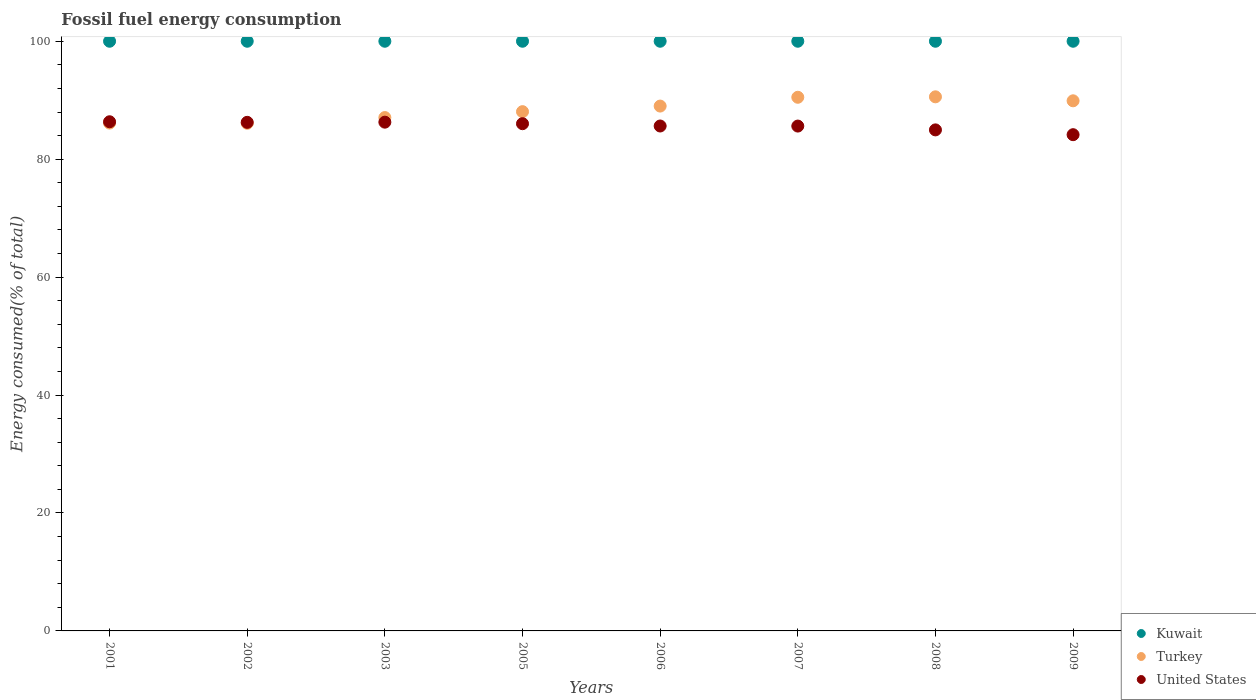How many different coloured dotlines are there?
Your answer should be very brief. 3. What is the percentage of energy consumed in United States in 2009?
Provide a succinct answer. 84.15. Across all years, what is the maximum percentage of energy consumed in Turkey?
Provide a short and direct response. 90.57. Across all years, what is the minimum percentage of energy consumed in Kuwait?
Give a very brief answer. 100. What is the total percentage of energy consumed in Turkey in the graph?
Offer a very short reply. 707.31. What is the difference between the percentage of energy consumed in Kuwait in 2005 and that in 2008?
Offer a terse response. 3.467057993589151e-6. What is the difference between the percentage of energy consumed in Kuwait in 2003 and the percentage of energy consumed in Turkey in 2008?
Your response must be concise. 9.43. What is the average percentage of energy consumed in Kuwait per year?
Ensure brevity in your answer.  100. In the year 2005, what is the difference between the percentage of energy consumed in United States and percentage of energy consumed in Kuwait?
Provide a succinct answer. -13.98. In how many years, is the percentage of energy consumed in United States greater than 60 %?
Give a very brief answer. 8. What is the ratio of the percentage of energy consumed in Turkey in 2007 to that in 2009?
Offer a terse response. 1.01. Is the percentage of energy consumed in United States in 2005 less than that in 2009?
Make the answer very short. No. What is the difference between the highest and the second highest percentage of energy consumed in United States?
Keep it short and to the point. 0.07. What is the difference between the highest and the lowest percentage of energy consumed in Turkey?
Make the answer very short. 4.49. In how many years, is the percentage of energy consumed in United States greater than the average percentage of energy consumed in United States taken over all years?
Your answer should be compact. 4. Is it the case that in every year, the sum of the percentage of energy consumed in Kuwait and percentage of energy consumed in Turkey  is greater than the percentage of energy consumed in United States?
Offer a terse response. Yes. Does the percentage of energy consumed in United States monotonically increase over the years?
Provide a short and direct response. No. Is the percentage of energy consumed in United States strictly less than the percentage of energy consumed in Kuwait over the years?
Ensure brevity in your answer.  Yes. How many dotlines are there?
Ensure brevity in your answer.  3. How many years are there in the graph?
Give a very brief answer. 8. Are the values on the major ticks of Y-axis written in scientific E-notation?
Your response must be concise. No. How many legend labels are there?
Your answer should be very brief. 3. How are the legend labels stacked?
Give a very brief answer. Vertical. What is the title of the graph?
Your response must be concise. Fossil fuel energy consumption. Does "New Caledonia" appear as one of the legend labels in the graph?
Give a very brief answer. No. What is the label or title of the Y-axis?
Your answer should be very brief. Energy consumed(% of total). What is the Energy consumed(% of total) of Turkey in 2001?
Provide a succinct answer. 86.12. What is the Energy consumed(% of total) in United States in 2001?
Keep it short and to the point. 86.35. What is the Energy consumed(% of total) of Kuwait in 2002?
Your answer should be very brief. 100. What is the Energy consumed(% of total) of Turkey in 2002?
Make the answer very short. 86.09. What is the Energy consumed(% of total) in United States in 2002?
Offer a very short reply. 86.25. What is the Energy consumed(% of total) in Kuwait in 2003?
Your response must be concise. 100. What is the Energy consumed(% of total) in Turkey in 2003?
Your response must be concise. 87.06. What is the Energy consumed(% of total) in United States in 2003?
Keep it short and to the point. 86.28. What is the Energy consumed(% of total) in Turkey in 2005?
Your answer should be compact. 88.06. What is the Energy consumed(% of total) of United States in 2005?
Provide a succinct answer. 86.02. What is the Energy consumed(% of total) of Kuwait in 2006?
Give a very brief answer. 100. What is the Energy consumed(% of total) of Turkey in 2006?
Ensure brevity in your answer.  89.01. What is the Energy consumed(% of total) of United States in 2006?
Give a very brief answer. 85.63. What is the Energy consumed(% of total) in Turkey in 2007?
Ensure brevity in your answer.  90.5. What is the Energy consumed(% of total) in United States in 2007?
Your response must be concise. 85.61. What is the Energy consumed(% of total) of Kuwait in 2008?
Ensure brevity in your answer.  100. What is the Energy consumed(% of total) of Turkey in 2008?
Your response must be concise. 90.57. What is the Energy consumed(% of total) in United States in 2008?
Provide a succinct answer. 84.97. What is the Energy consumed(% of total) of Turkey in 2009?
Give a very brief answer. 89.9. What is the Energy consumed(% of total) of United States in 2009?
Your answer should be compact. 84.15. Across all years, what is the maximum Energy consumed(% of total) in Turkey?
Offer a terse response. 90.57. Across all years, what is the maximum Energy consumed(% of total) in United States?
Your answer should be compact. 86.35. Across all years, what is the minimum Energy consumed(% of total) in Kuwait?
Make the answer very short. 100. Across all years, what is the minimum Energy consumed(% of total) of Turkey?
Offer a terse response. 86.09. Across all years, what is the minimum Energy consumed(% of total) in United States?
Offer a very short reply. 84.15. What is the total Energy consumed(% of total) in Kuwait in the graph?
Your response must be concise. 800. What is the total Energy consumed(% of total) of Turkey in the graph?
Offer a very short reply. 707.31. What is the total Energy consumed(% of total) in United States in the graph?
Give a very brief answer. 685.26. What is the difference between the Energy consumed(% of total) in Turkey in 2001 and that in 2002?
Offer a very short reply. 0.04. What is the difference between the Energy consumed(% of total) of United States in 2001 and that in 2002?
Offer a terse response. 0.1. What is the difference between the Energy consumed(% of total) in Kuwait in 2001 and that in 2003?
Ensure brevity in your answer.  0. What is the difference between the Energy consumed(% of total) of Turkey in 2001 and that in 2003?
Give a very brief answer. -0.93. What is the difference between the Energy consumed(% of total) in United States in 2001 and that in 2003?
Ensure brevity in your answer.  0.07. What is the difference between the Energy consumed(% of total) in Kuwait in 2001 and that in 2005?
Provide a short and direct response. 0. What is the difference between the Energy consumed(% of total) in Turkey in 2001 and that in 2005?
Give a very brief answer. -1.94. What is the difference between the Energy consumed(% of total) in United States in 2001 and that in 2005?
Ensure brevity in your answer.  0.33. What is the difference between the Energy consumed(% of total) of Turkey in 2001 and that in 2006?
Your answer should be very brief. -2.88. What is the difference between the Energy consumed(% of total) of United States in 2001 and that in 2006?
Make the answer very short. 0.72. What is the difference between the Energy consumed(% of total) of Turkey in 2001 and that in 2007?
Make the answer very short. -4.37. What is the difference between the Energy consumed(% of total) of United States in 2001 and that in 2007?
Make the answer very short. 0.73. What is the difference between the Energy consumed(% of total) in Turkey in 2001 and that in 2008?
Your answer should be compact. -4.45. What is the difference between the Energy consumed(% of total) of United States in 2001 and that in 2008?
Offer a terse response. 1.38. What is the difference between the Energy consumed(% of total) in Kuwait in 2001 and that in 2009?
Provide a short and direct response. 0. What is the difference between the Energy consumed(% of total) in Turkey in 2001 and that in 2009?
Provide a succinct answer. -3.78. What is the difference between the Energy consumed(% of total) of United States in 2001 and that in 2009?
Offer a very short reply. 2.19. What is the difference between the Energy consumed(% of total) in Turkey in 2002 and that in 2003?
Your answer should be compact. -0.97. What is the difference between the Energy consumed(% of total) in United States in 2002 and that in 2003?
Your answer should be compact. -0.03. What is the difference between the Energy consumed(% of total) in Turkey in 2002 and that in 2005?
Provide a short and direct response. -1.97. What is the difference between the Energy consumed(% of total) in United States in 2002 and that in 2005?
Ensure brevity in your answer.  0.23. What is the difference between the Energy consumed(% of total) in Kuwait in 2002 and that in 2006?
Give a very brief answer. 0. What is the difference between the Energy consumed(% of total) of Turkey in 2002 and that in 2006?
Provide a succinct answer. -2.92. What is the difference between the Energy consumed(% of total) in United States in 2002 and that in 2006?
Keep it short and to the point. 0.62. What is the difference between the Energy consumed(% of total) in Kuwait in 2002 and that in 2007?
Offer a very short reply. 0. What is the difference between the Energy consumed(% of total) of Turkey in 2002 and that in 2007?
Make the answer very short. -4.41. What is the difference between the Energy consumed(% of total) in United States in 2002 and that in 2007?
Offer a terse response. 0.63. What is the difference between the Energy consumed(% of total) of Turkey in 2002 and that in 2008?
Your answer should be very brief. -4.49. What is the difference between the Energy consumed(% of total) in United States in 2002 and that in 2008?
Make the answer very short. 1.28. What is the difference between the Energy consumed(% of total) in Turkey in 2002 and that in 2009?
Provide a succinct answer. -3.81. What is the difference between the Energy consumed(% of total) of United States in 2002 and that in 2009?
Your answer should be compact. 2.09. What is the difference between the Energy consumed(% of total) in Kuwait in 2003 and that in 2005?
Provide a succinct answer. -0. What is the difference between the Energy consumed(% of total) in Turkey in 2003 and that in 2005?
Offer a very short reply. -1. What is the difference between the Energy consumed(% of total) in United States in 2003 and that in 2005?
Keep it short and to the point. 0.26. What is the difference between the Energy consumed(% of total) of Turkey in 2003 and that in 2006?
Your answer should be compact. -1.95. What is the difference between the Energy consumed(% of total) in United States in 2003 and that in 2006?
Provide a succinct answer. 0.65. What is the difference between the Energy consumed(% of total) in Kuwait in 2003 and that in 2007?
Provide a succinct answer. -0. What is the difference between the Energy consumed(% of total) in Turkey in 2003 and that in 2007?
Keep it short and to the point. -3.44. What is the difference between the Energy consumed(% of total) in United States in 2003 and that in 2007?
Offer a terse response. 0.66. What is the difference between the Energy consumed(% of total) in Kuwait in 2003 and that in 2008?
Give a very brief answer. -0. What is the difference between the Energy consumed(% of total) of Turkey in 2003 and that in 2008?
Offer a terse response. -3.52. What is the difference between the Energy consumed(% of total) in United States in 2003 and that in 2008?
Offer a terse response. 1.31. What is the difference between the Energy consumed(% of total) of Kuwait in 2003 and that in 2009?
Offer a very short reply. -0. What is the difference between the Energy consumed(% of total) of Turkey in 2003 and that in 2009?
Ensure brevity in your answer.  -2.84. What is the difference between the Energy consumed(% of total) in United States in 2003 and that in 2009?
Offer a terse response. 2.12. What is the difference between the Energy consumed(% of total) in Kuwait in 2005 and that in 2006?
Make the answer very short. 0. What is the difference between the Energy consumed(% of total) of Turkey in 2005 and that in 2006?
Provide a succinct answer. -0.95. What is the difference between the Energy consumed(% of total) of United States in 2005 and that in 2006?
Your response must be concise. 0.39. What is the difference between the Energy consumed(% of total) of Turkey in 2005 and that in 2007?
Your answer should be very brief. -2.44. What is the difference between the Energy consumed(% of total) in United States in 2005 and that in 2007?
Keep it short and to the point. 0.4. What is the difference between the Energy consumed(% of total) of Kuwait in 2005 and that in 2008?
Offer a terse response. 0. What is the difference between the Energy consumed(% of total) in Turkey in 2005 and that in 2008?
Offer a very short reply. -2.52. What is the difference between the Energy consumed(% of total) of United States in 2005 and that in 2008?
Provide a succinct answer. 1.05. What is the difference between the Energy consumed(% of total) of Kuwait in 2005 and that in 2009?
Keep it short and to the point. 0. What is the difference between the Energy consumed(% of total) of Turkey in 2005 and that in 2009?
Keep it short and to the point. -1.84. What is the difference between the Energy consumed(% of total) in United States in 2005 and that in 2009?
Your response must be concise. 1.86. What is the difference between the Energy consumed(% of total) in Kuwait in 2006 and that in 2007?
Offer a very short reply. 0. What is the difference between the Energy consumed(% of total) of Turkey in 2006 and that in 2007?
Give a very brief answer. -1.49. What is the difference between the Energy consumed(% of total) of United States in 2006 and that in 2007?
Your answer should be compact. 0.01. What is the difference between the Energy consumed(% of total) in Kuwait in 2006 and that in 2008?
Keep it short and to the point. 0. What is the difference between the Energy consumed(% of total) in Turkey in 2006 and that in 2008?
Keep it short and to the point. -1.57. What is the difference between the Energy consumed(% of total) of United States in 2006 and that in 2008?
Your answer should be compact. 0.66. What is the difference between the Energy consumed(% of total) of Turkey in 2006 and that in 2009?
Your answer should be very brief. -0.89. What is the difference between the Energy consumed(% of total) in United States in 2006 and that in 2009?
Provide a short and direct response. 1.47. What is the difference between the Energy consumed(% of total) of Turkey in 2007 and that in 2008?
Offer a very short reply. -0.08. What is the difference between the Energy consumed(% of total) in United States in 2007 and that in 2008?
Keep it short and to the point. 0.65. What is the difference between the Energy consumed(% of total) in Turkey in 2007 and that in 2009?
Offer a terse response. 0.6. What is the difference between the Energy consumed(% of total) in United States in 2007 and that in 2009?
Give a very brief answer. 1.46. What is the difference between the Energy consumed(% of total) of Kuwait in 2008 and that in 2009?
Provide a short and direct response. -0. What is the difference between the Energy consumed(% of total) of Turkey in 2008 and that in 2009?
Ensure brevity in your answer.  0.68. What is the difference between the Energy consumed(% of total) of United States in 2008 and that in 2009?
Keep it short and to the point. 0.81. What is the difference between the Energy consumed(% of total) of Kuwait in 2001 and the Energy consumed(% of total) of Turkey in 2002?
Provide a succinct answer. 13.91. What is the difference between the Energy consumed(% of total) in Kuwait in 2001 and the Energy consumed(% of total) in United States in 2002?
Ensure brevity in your answer.  13.75. What is the difference between the Energy consumed(% of total) of Turkey in 2001 and the Energy consumed(% of total) of United States in 2002?
Offer a terse response. -0.13. What is the difference between the Energy consumed(% of total) in Kuwait in 2001 and the Energy consumed(% of total) in Turkey in 2003?
Offer a very short reply. 12.94. What is the difference between the Energy consumed(% of total) of Kuwait in 2001 and the Energy consumed(% of total) of United States in 2003?
Keep it short and to the point. 13.72. What is the difference between the Energy consumed(% of total) of Turkey in 2001 and the Energy consumed(% of total) of United States in 2003?
Keep it short and to the point. -0.15. What is the difference between the Energy consumed(% of total) of Kuwait in 2001 and the Energy consumed(% of total) of Turkey in 2005?
Your answer should be very brief. 11.94. What is the difference between the Energy consumed(% of total) in Kuwait in 2001 and the Energy consumed(% of total) in United States in 2005?
Make the answer very short. 13.98. What is the difference between the Energy consumed(% of total) in Turkey in 2001 and the Energy consumed(% of total) in United States in 2005?
Ensure brevity in your answer.  0.11. What is the difference between the Energy consumed(% of total) of Kuwait in 2001 and the Energy consumed(% of total) of Turkey in 2006?
Provide a short and direct response. 10.99. What is the difference between the Energy consumed(% of total) in Kuwait in 2001 and the Energy consumed(% of total) in United States in 2006?
Your response must be concise. 14.37. What is the difference between the Energy consumed(% of total) in Turkey in 2001 and the Energy consumed(% of total) in United States in 2006?
Your answer should be very brief. 0.5. What is the difference between the Energy consumed(% of total) of Kuwait in 2001 and the Energy consumed(% of total) of Turkey in 2007?
Ensure brevity in your answer.  9.5. What is the difference between the Energy consumed(% of total) in Kuwait in 2001 and the Energy consumed(% of total) in United States in 2007?
Offer a terse response. 14.39. What is the difference between the Energy consumed(% of total) of Turkey in 2001 and the Energy consumed(% of total) of United States in 2007?
Your response must be concise. 0.51. What is the difference between the Energy consumed(% of total) of Kuwait in 2001 and the Energy consumed(% of total) of Turkey in 2008?
Keep it short and to the point. 9.43. What is the difference between the Energy consumed(% of total) of Kuwait in 2001 and the Energy consumed(% of total) of United States in 2008?
Provide a succinct answer. 15.03. What is the difference between the Energy consumed(% of total) in Turkey in 2001 and the Energy consumed(% of total) in United States in 2008?
Ensure brevity in your answer.  1.16. What is the difference between the Energy consumed(% of total) of Kuwait in 2001 and the Energy consumed(% of total) of Turkey in 2009?
Your answer should be very brief. 10.1. What is the difference between the Energy consumed(% of total) in Kuwait in 2001 and the Energy consumed(% of total) in United States in 2009?
Make the answer very short. 15.85. What is the difference between the Energy consumed(% of total) of Turkey in 2001 and the Energy consumed(% of total) of United States in 2009?
Your answer should be very brief. 1.97. What is the difference between the Energy consumed(% of total) of Kuwait in 2002 and the Energy consumed(% of total) of Turkey in 2003?
Offer a terse response. 12.94. What is the difference between the Energy consumed(% of total) in Kuwait in 2002 and the Energy consumed(% of total) in United States in 2003?
Provide a succinct answer. 13.72. What is the difference between the Energy consumed(% of total) of Turkey in 2002 and the Energy consumed(% of total) of United States in 2003?
Your answer should be very brief. -0.19. What is the difference between the Energy consumed(% of total) in Kuwait in 2002 and the Energy consumed(% of total) in Turkey in 2005?
Make the answer very short. 11.94. What is the difference between the Energy consumed(% of total) in Kuwait in 2002 and the Energy consumed(% of total) in United States in 2005?
Your answer should be compact. 13.98. What is the difference between the Energy consumed(% of total) of Turkey in 2002 and the Energy consumed(% of total) of United States in 2005?
Offer a terse response. 0.07. What is the difference between the Energy consumed(% of total) in Kuwait in 2002 and the Energy consumed(% of total) in Turkey in 2006?
Make the answer very short. 10.99. What is the difference between the Energy consumed(% of total) of Kuwait in 2002 and the Energy consumed(% of total) of United States in 2006?
Provide a succinct answer. 14.37. What is the difference between the Energy consumed(% of total) in Turkey in 2002 and the Energy consumed(% of total) in United States in 2006?
Provide a short and direct response. 0.46. What is the difference between the Energy consumed(% of total) of Kuwait in 2002 and the Energy consumed(% of total) of Turkey in 2007?
Keep it short and to the point. 9.5. What is the difference between the Energy consumed(% of total) in Kuwait in 2002 and the Energy consumed(% of total) in United States in 2007?
Your answer should be very brief. 14.39. What is the difference between the Energy consumed(% of total) in Turkey in 2002 and the Energy consumed(% of total) in United States in 2007?
Your response must be concise. 0.47. What is the difference between the Energy consumed(% of total) of Kuwait in 2002 and the Energy consumed(% of total) of Turkey in 2008?
Make the answer very short. 9.43. What is the difference between the Energy consumed(% of total) of Kuwait in 2002 and the Energy consumed(% of total) of United States in 2008?
Offer a terse response. 15.03. What is the difference between the Energy consumed(% of total) in Turkey in 2002 and the Energy consumed(% of total) in United States in 2008?
Your response must be concise. 1.12. What is the difference between the Energy consumed(% of total) in Kuwait in 2002 and the Energy consumed(% of total) in Turkey in 2009?
Your answer should be very brief. 10.1. What is the difference between the Energy consumed(% of total) of Kuwait in 2002 and the Energy consumed(% of total) of United States in 2009?
Your answer should be compact. 15.85. What is the difference between the Energy consumed(% of total) of Turkey in 2002 and the Energy consumed(% of total) of United States in 2009?
Make the answer very short. 1.93. What is the difference between the Energy consumed(% of total) in Kuwait in 2003 and the Energy consumed(% of total) in Turkey in 2005?
Provide a succinct answer. 11.94. What is the difference between the Energy consumed(% of total) of Kuwait in 2003 and the Energy consumed(% of total) of United States in 2005?
Offer a terse response. 13.98. What is the difference between the Energy consumed(% of total) in Turkey in 2003 and the Energy consumed(% of total) in United States in 2005?
Ensure brevity in your answer.  1.04. What is the difference between the Energy consumed(% of total) of Kuwait in 2003 and the Energy consumed(% of total) of Turkey in 2006?
Make the answer very short. 10.99. What is the difference between the Energy consumed(% of total) of Kuwait in 2003 and the Energy consumed(% of total) of United States in 2006?
Offer a very short reply. 14.37. What is the difference between the Energy consumed(% of total) in Turkey in 2003 and the Energy consumed(% of total) in United States in 2006?
Provide a short and direct response. 1.43. What is the difference between the Energy consumed(% of total) of Kuwait in 2003 and the Energy consumed(% of total) of Turkey in 2007?
Your answer should be compact. 9.5. What is the difference between the Energy consumed(% of total) in Kuwait in 2003 and the Energy consumed(% of total) in United States in 2007?
Keep it short and to the point. 14.39. What is the difference between the Energy consumed(% of total) in Turkey in 2003 and the Energy consumed(% of total) in United States in 2007?
Your answer should be compact. 1.44. What is the difference between the Energy consumed(% of total) of Kuwait in 2003 and the Energy consumed(% of total) of Turkey in 2008?
Keep it short and to the point. 9.43. What is the difference between the Energy consumed(% of total) of Kuwait in 2003 and the Energy consumed(% of total) of United States in 2008?
Your answer should be compact. 15.03. What is the difference between the Energy consumed(% of total) of Turkey in 2003 and the Energy consumed(% of total) of United States in 2008?
Offer a terse response. 2.09. What is the difference between the Energy consumed(% of total) of Kuwait in 2003 and the Energy consumed(% of total) of Turkey in 2009?
Your answer should be compact. 10.1. What is the difference between the Energy consumed(% of total) in Kuwait in 2003 and the Energy consumed(% of total) in United States in 2009?
Your response must be concise. 15.85. What is the difference between the Energy consumed(% of total) of Turkey in 2003 and the Energy consumed(% of total) of United States in 2009?
Your answer should be compact. 2.9. What is the difference between the Energy consumed(% of total) of Kuwait in 2005 and the Energy consumed(% of total) of Turkey in 2006?
Keep it short and to the point. 10.99. What is the difference between the Energy consumed(% of total) of Kuwait in 2005 and the Energy consumed(% of total) of United States in 2006?
Provide a short and direct response. 14.37. What is the difference between the Energy consumed(% of total) in Turkey in 2005 and the Energy consumed(% of total) in United States in 2006?
Provide a short and direct response. 2.43. What is the difference between the Energy consumed(% of total) in Kuwait in 2005 and the Energy consumed(% of total) in Turkey in 2007?
Provide a short and direct response. 9.5. What is the difference between the Energy consumed(% of total) in Kuwait in 2005 and the Energy consumed(% of total) in United States in 2007?
Make the answer very short. 14.39. What is the difference between the Energy consumed(% of total) in Turkey in 2005 and the Energy consumed(% of total) in United States in 2007?
Keep it short and to the point. 2.44. What is the difference between the Energy consumed(% of total) in Kuwait in 2005 and the Energy consumed(% of total) in Turkey in 2008?
Offer a very short reply. 9.43. What is the difference between the Energy consumed(% of total) of Kuwait in 2005 and the Energy consumed(% of total) of United States in 2008?
Keep it short and to the point. 15.03. What is the difference between the Energy consumed(% of total) of Turkey in 2005 and the Energy consumed(% of total) of United States in 2008?
Offer a very short reply. 3.09. What is the difference between the Energy consumed(% of total) in Kuwait in 2005 and the Energy consumed(% of total) in Turkey in 2009?
Your response must be concise. 10.1. What is the difference between the Energy consumed(% of total) in Kuwait in 2005 and the Energy consumed(% of total) in United States in 2009?
Make the answer very short. 15.85. What is the difference between the Energy consumed(% of total) in Turkey in 2005 and the Energy consumed(% of total) in United States in 2009?
Offer a terse response. 3.91. What is the difference between the Energy consumed(% of total) in Kuwait in 2006 and the Energy consumed(% of total) in Turkey in 2007?
Ensure brevity in your answer.  9.5. What is the difference between the Energy consumed(% of total) of Kuwait in 2006 and the Energy consumed(% of total) of United States in 2007?
Give a very brief answer. 14.39. What is the difference between the Energy consumed(% of total) of Turkey in 2006 and the Energy consumed(% of total) of United States in 2007?
Offer a terse response. 3.39. What is the difference between the Energy consumed(% of total) of Kuwait in 2006 and the Energy consumed(% of total) of Turkey in 2008?
Your response must be concise. 9.43. What is the difference between the Energy consumed(% of total) of Kuwait in 2006 and the Energy consumed(% of total) of United States in 2008?
Provide a short and direct response. 15.03. What is the difference between the Energy consumed(% of total) of Turkey in 2006 and the Energy consumed(% of total) of United States in 2008?
Your answer should be very brief. 4.04. What is the difference between the Energy consumed(% of total) of Kuwait in 2006 and the Energy consumed(% of total) of Turkey in 2009?
Offer a very short reply. 10.1. What is the difference between the Energy consumed(% of total) of Kuwait in 2006 and the Energy consumed(% of total) of United States in 2009?
Give a very brief answer. 15.85. What is the difference between the Energy consumed(% of total) in Turkey in 2006 and the Energy consumed(% of total) in United States in 2009?
Provide a succinct answer. 4.85. What is the difference between the Energy consumed(% of total) in Kuwait in 2007 and the Energy consumed(% of total) in Turkey in 2008?
Ensure brevity in your answer.  9.43. What is the difference between the Energy consumed(% of total) in Kuwait in 2007 and the Energy consumed(% of total) in United States in 2008?
Provide a short and direct response. 15.03. What is the difference between the Energy consumed(% of total) in Turkey in 2007 and the Energy consumed(% of total) in United States in 2008?
Your answer should be very brief. 5.53. What is the difference between the Energy consumed(% of total) of Kuwait in 2007 and the Energy consumed(% of total) of Turkey in 2009?
Give a very brief answer. 10.1. What is the difference between the Energy consumed(% of total) of Kuwait in 2007 and the Energy consumed(% of total) of United States in 2009?
Ensure brevity in your answer.  15.85. What is the difference between the Energy consumed(% of total) in Turkey in 2007 and the Energy consumed(% of total) in United States in 2009?
Provide a succinct answer. 6.34. What is the difference between the Energy consumed(% of total) in Kuwait in 2008 and the Energy consumed(% of total) in Turkey in 2009?
Offer a very short reply. 10.1. What is the difference between the Energy consumed(% of total) of Kuwait in 2008 and the Energy consumed(% of total) of United States in 2009?
Your answer should be compact. 15.85. What is the difference between the Energy consumed(% of total) of Turkey in 2008 and the Energy consumed(% of total) of United States in 2009?
Your response must be concise. 6.42. What is the average Energy consumed(% of total) in Kuwait per year?
Provide a short and direct response. 100. What is the average Energy consumed(% of total) of Turkey per year?
Your answer should be very brief. 88.41. What is the average Energy consumed(% of total) of United States per year?
Your answer should be very brief. 85.66. In the year 2001, what is the difference between the Energy consumed(% of total) in Kuwait and Energy consumed(% of total) in Turkey?
Keep it short and to the point. 13.88. In the year 2001, what is the difference between the Energy consumed(% of total) in Kuwait and Energy consumed(% of total) in United States?
Offer a terse response. 13.65. In the year 2001, what is the difference between the Energy consumed(% of total) of Turkey and Energy consumed(% of total) of United States?
Make the answer very short. -0.22. In the year 2002, what is the difference between the Energy consumed(% of total) in Kuwait and Energy consumed(% of total) in Turkey?
Provide a succinct answer. 13.91. In the year 2002, what is the difference between the Energy consumed(% of total) of Kuwait and Energy consumed(% of total) of United States?
Your answer should be very brief. 13.75. In the year 2002, what is the difference between the Energy consumed(% of total) of Turkey and Energy consumed(% of total) of United States?
Your answer should be compact. -0.16. In the year 2003, what is the difference between the Energy consumed(% of total) of Kuwait and Energy consumed(% of total) of Turkey?
Provide a succinct answer. 12.94. In the year 2003, what is the difference between the Energy consumed(% of total) in Kuwait and Energy consumed(% of total) in United States?
Your answer should be very brief. 13.72. In the year 2003, what is the difference between the Energy consumed(% of total) in Turkey and Energy consumed(% of total) in United States?
Ensure brevity in your answer.  0.78. In the year 2005, what is the difference between the Energy consumed(% of total) in Kuwait and Energy consumed(% of total) in Turkey?
Offer a very short reply. 11.94. In the year 2005, what is the difference between the Energy consumed(% of total) in Kuwait and Energy consumed(% of total) in United States?
Keep it short and to the point. 13.98. In the year 2005, what is the difference between the Energy consumed(% of total) in Turkey and Energy consumed(% of total) in United States?
Make the answer very short. 2.04. In the year 2006, what is the difference between the Energy consumed(% of total) of Kuwait and Energy consumed(% of total) of Turkey?
Keep it short and to the point. 10.99. In the year 2006, what is the difference between the Energy consumed(% of total) of Kuwait and Energy consumed(% of total) of United States?
Offer a terse response. 14.37. In the year 2006, what is the difference between the Energy consumed(% of total) in Turkey and Energy consumed(% of total) in United States?
Provide a succinct answer. 3.38. In the year 2007, what is the difference between the Energy consumed(% of total) of Kuwait and Energy consumed(% of total) of Turkey?
Make the answer very short. 9.5. In the year 2007, what is the difference between the Energy consumed(% of total) in Kuwait and Energy consumed(% of total) in United States?
Ensure brevity in your answer.  14.39. In the year 2007, what is the difference between the Energy consumed(% of total) of Turkey and Energy consumed(% of total) of United States?
Your answer should be compact. 4.88. In the year 2008, what is the difference between the Energy consumed(% of total) of Kuwait and Energy consumed(% of total) of Turkey?
Provide a succinct answer. 9.43. In the year 2008, what is the difference between the Energy consumed(% of total) of Kuwait and Energy consumed(% of total) of United States?
Provide a short and direct response. 15.03. In the year 2008, what is the difference between the Energy consumed(% of total) in Turkey and Energy consumed(% of total) in United States?
Your response must be concise. 5.61. In the year 2009, what is the difference between the Energy consumed(% of total) in Kuwait and Energy consumed(% of total) in Turkey?
Make the answer very short. 10.1. In the year 2009, what is the difference between the Energy consumed(% of total) of Kuwait and Energy consumed(% of total) of United States?
Offer a terse response. 15.85. In the year 2009, what is the difference between the Energy consumed(% of total) of Turkey and Energy consumed(% of total) of United States?
Your answer should be compact. 5.75. What is the ratio of the Energy consumed(% of total) of Turkey in 2001 to that in 2002?
Make the answer very short. 1. What is the ratio of the Energy consumed(% of total) of Turkey in 2001 to that in 2003?
Give a very brief answer. 0.99. What is the ratio of the Energy consumed(% of total) in Kuwait in 2001 to that in 2005?
Ensure brevity in your answer.  1. What is the ratio of the Energy consumed(% of total) of Turkey in 2001 to that in 2005?
Provide a short and direct response. 0.98. What is the ratio of the Energy consumed(% of total) in Turkey in 2001 to that in 2006?
Your response must be concise. 0.97. What is the ratio of the Energy consumed(% of total) of United States in 2001 to that in 2006?
Keep it short and to the point. 1.01. What is the ratio of the Energy consumed(% of total) in Turkey in 2001 to that in 2007?
Make the answer very short. 0.95. What is the ratio of the Energy consumed(% of total) in United States in 2001 to that in 2007?
Make the answer very short. 1.01. What is the ratio of the Energy consumed(% of total) of Kuwait in 2001 to that in 2008?
Your answer should be very brief. 1. What is the ratio of the Energy consumed(% of total) of Turkey in 2001 to that in 2008?
Offer a very short reply. 0.95. What is the ratio of the Energy consumed(% of total) of United States in 2001 to that in 2008?
Offer a terse response. 1.02. What is the ratio of the Energy consumed(% of total) of Turkey in 2001 to that in 2009?
Make the answer very short. 0.96. What is the ratio of the Energy consumed(% of total) in United States in 2001 to that in 2009?
Your answer should be compact. 1.03. What is the ratio of the Energy consumed(% of total) in Turkey in 2002 to that in 2003?
Keep it short and to the point. 0.99. What is the ratio of the Energy consumed(% of total) in United States in 2002 to that in 2003?
Your answer should be very brief. 1. What is the ratio of the Energy consumed(% of total) of Turkey in 2002 to that in 2005?
Your answer should be compact. 0.98. What is the ratio of the Energy consumed(% of total) in United States in 2002 to that in 2005?
Give a very brief answer. 1. What is the ratio of the Energy consumed(% of total) in Turkey in 2002 to that in 2006?
Keep it short and to the point. 0.97. What is the ratio of the Energy consumed(% of total) of United States in 2002 to that in 2006?
Your answer should be compact. 1.01. What is the ratio of the Energy consumed(% of total) of Turkey in 2002 to that in 2007?
Your answer should be compact. 0.95. What is the ratio of the Energy consumed(% of total) in United States in 2002 to that in 2007?
Keep it short and to the point. 1.01. What is the ratio of the Energy consumed(% of total) of Turkey in 2002 to that in 2008?
Offer a very short reply. 0.95. What is the ratio of the Energy consumed(% of total) in United States in 2002 to that in 2008?
Make the answer very short. 1.02. What is the ratio of the Energy consumed(% of total) in Kuwait in 2002 to that in 2009?
Your answer should be very brief. 1. What is the ratio of the Energy consumed(% of total) of Turkey in 2002 to that in 2009?
Make the answer very short. 0.96. What is the ratio of the Energy consumed(% of total) of United States in 2002 to that in 2009?
Your answer should be very brief. 1.02. What is the ratio of the Energy consumed(% of total) of Kuwait in 2003 to that in 2005?
Provide a succinct answer. 1. What is the ratio of the Energy consumed(% of total) in Kuwait in 2003 to that in 2006?
Make the answer very short. 1. What is the ratio of the Energy consumed(% of total) in Turkey in 2003 to that in 2006?
Keep it short and to the point. 0.98. What is the ratio of the Energy consumed(% of total) of United States in 2003 to that in 2006?
Keep it short and to the point. 1.01. What is the ratio of the Energy consumed(% of total) of Kuwait in 2003 to that in 2007?
Your answer should be very brief. 1. What is the ratio of the Energy consumed(% of total) in Turkey in 2003 to that in 2007?
Offer a very short reply. 0.96. What is the ratio of the Energy consumed(% of total) in Kuwait in 2003 to that in 2008?
Provide a short and direct response. 1. What is the ratio of the Energy consumed(% of total) in Turkey in 2003 to that in 2008?
Make the answer very short. 0.96. What is the ratio of the Energy consumed(% of total) of United States in 2003 to that in 2008?
Ensure brevity in your answer.  1.02. What is the ratio of the Energy consumed(% of total) of Kuwait in 2003 to that in 2009?
Ensure brevity in your answer.  1. What is the ratio of the Energy consumed(% of total) in Turkey in 2003 to that in 2009?
Offer a terse response. 0.97. What is the ratio of the Energy consumed(% of total) in United States in 2003 to that in 2009?
Ensure brevity in your answer.  1.03. What is the ratio of the Energy consumed(% of total) in Turkey in 2005 to that in 2007?
Offer a terse response. 0.97. What is the ratio of the Energy consumed(% of total) in United States in 2005 to that in 2007?
Provide a short and direct response. 1. What is the ratio of the Energy consumed(% of total) in Turkey in 2005 to that in 2008?
Give a very brief answer. 0.97. What is the ratio of the Energy consumed(% of total) of United States in 2005 to that in 2008?
Give a very brief answer. 1.01. What is the ratio of the Energy consumed(% of total) of Turkey in 2005 to that in 2009?
Provide a succinct answer. 0.98. What is the ratio of the Energy consumed(% of total) of United States in 2005 to that in 2009?
Offer a terse response. 1.02. What is the ratio of the Energy consumed(% of total) of Turkey in 2006 to that in 2007?
Ensure brevity in your answer.  0.98. What is the ratio of the Energy consumed(% of total) of Turkey in 2006 to that in 2008?
Provide a succinct answer. 0.98. What is the ratio of the Energy consumed(% of total) in United States in 2006 to that in 2008?
Make the answer very short. 1.01. What is the ratio of the Energy consumed(% of total) in Kuwait in 2006 to that in 2009?
Keep it short and to the point. 1. What is the ratio of the Energy consumed(% of total) of United States in 2006 to that in 2009?
Keep it short and to the point. 1.02. What is the ratio of the Energy consumed(% of total) of Turkey in 2007 to that in 2008?
Provide a succinct answer. 1. What is the ratio of the Energy consumed(% of total) in United States in 2007 to that in 2008?
Your response must be concise. 1.01. What is the ratio of the Energy consumed(% of total) in Turkey in 2007 to that in 2009?
Your answer should be compact. 1.01. What is the ratio of the Energy consumed(% of total) in United States in 2007 to that in 2009?
Your answer should be compact. 1.02. What is the ratio of the Energy consumed(% of total) of Turkey in 2008 to that in 2009?
Provide a short and direct response. 1.01. What is the ratio of the Energy consumed(% of total) of United States in 2008 to that in 2009?
Keep it short and to the point. 1.01. What is the difference between the highest and the second highest Energy consumed(% of total) of Kuwait?
Provide a short and direct response. 0. What is the difference between the highest and the second highest Energy consumed(% of total) of Turkey?
Your answer should be compact. 0.08. What is the difference between the highest and the second highest Energy consumed(% of total) in United States?
Give a very brief answer. 0.07. What is the difference between the highest and the lowest Energy consumed(% of total) in Turkey?
Your answer should be very brief. 4.49. What is the difference between the highest and the lowest Energy consumed(% of total) of United States?
Your answer should be compact. 2.19. 